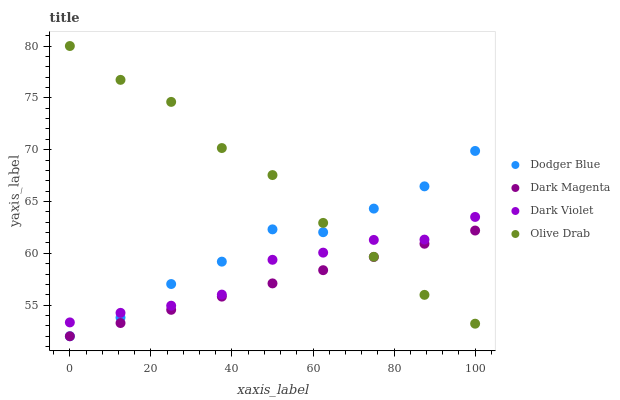Does Dark Magenta have the minimum area under the curve?
Answer yes or no. Yes. Does Olive Drab have the maximum area under the curve?
Answer yes or no. Yes. Does Dodger Blue have the minimum area under the curve?
Answer yes or no. No. Does Dodger Blue have the maximum area under the curve?
Answer yes or no. No. Is Dark Magenta the smoothest?
Answer yes or no. Yes. Is Dodger Blue the roughest?
Answer yes or no. Yes. Is Dodger Blue the smoothest?
Answer yes or no. No. Is Dark Magenta the roughest?
Answer yes or no. No. Does Dodger Blue have the lowest value?
Answer yes or no. Yes. Does Dark Violet have the lowest value?
Answer yes or no. No. Does Olive Drab have the highest value?
Answer yes or no. Yes. Does Dodger Blue have the highest value?
Answer yes or no. No. Is Dark Magenta less than Dark Violet?
Answer yes or no. Yes. Is Dark Violet greater than Dark Magenta?
Answer yes or no. Yes. Does Olive Drab intersect Dodger Blue?
Answer yes or no. Yes. Is Olive Drab less than Dodger Blue?
Answer yes or no. No. Is Olive Drab greater than Dodger Blue?
Answer yes or no. No. Does Dark Magenta intersect Dark Violet?
Answer yes or no. No. 